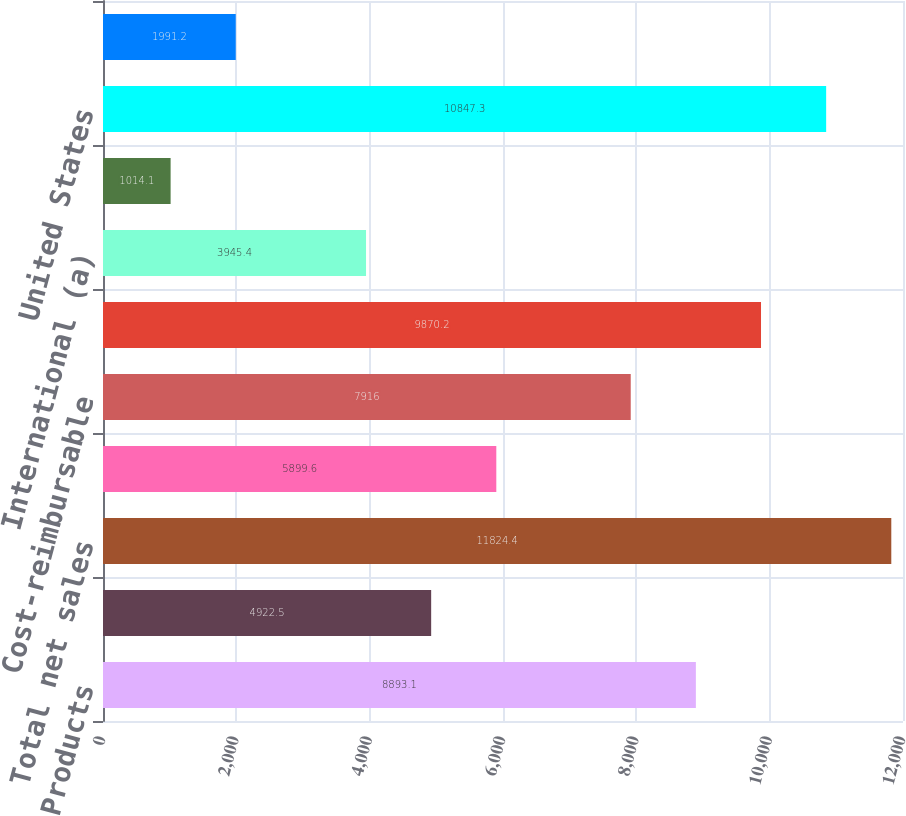<chart> <loc_0><loc_0><loc_500><loc_500><bar_chart><fcel>Products<fcel>Services<fcel>Total net sales<fcel>Fixed-price<fcel>Cost-reimbursable<fcel>US Government<fcel>International (a)<fcel>US commercial and other<fcel>United States<fcel>Asia Pacific<nl><fcel>8893.1<fcel>4922.5<fcel>11824.4<fcel>5899.6<fcel>7916<fcel>9870.2<fcel>3945.4<fcel>1014.1<fcel>10847.3<fcel>1991.2<nl></chart> 